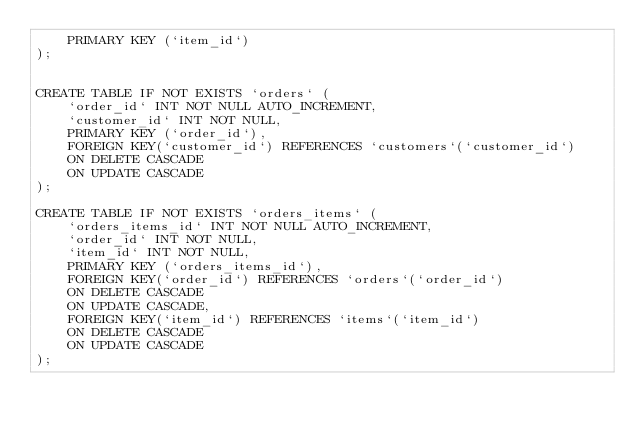<code> <loc_0><loc_0><loc_500><loc_500><_SQL_>    PRIMARY KEY (`item_id`)
);


CREATE TABLE IF NOT EXISTS `orders` (
    `order_id` INT NOT NULL AUTO_INCREMENT,
    `customer_id` INT NOT NULL,
    PRIMARY KEY (`order_id`),
	FOREIGN KEY(`customer_id`) REFERENCES `customers`(`customer_id`)
	ON DELETE CASCADE
  	ON UPDATE CASCADE
);

CREATE TABLE IF NOT EXISTS `orders_items` (
    `orders_items_id` INT NOT NULL AUTO_INCREMENT,
    `order_id` INT NOT NULL,
    `item_id` INT NOT NULL,
    PRIMARY KEY (`orders_items_id`),
	FOREIGN KEY(`order_id`) REFERENCES `orders`(`order_id`)
	ON DELETE CASCADE
  	ON UPDATE CASCADE,
	FOREIGN KEY(`item_id`) REFERENCES `items`(`item_id`)
	ON DELETE CASCADE
  	ON UPDATE CASCADE
);



</code> 